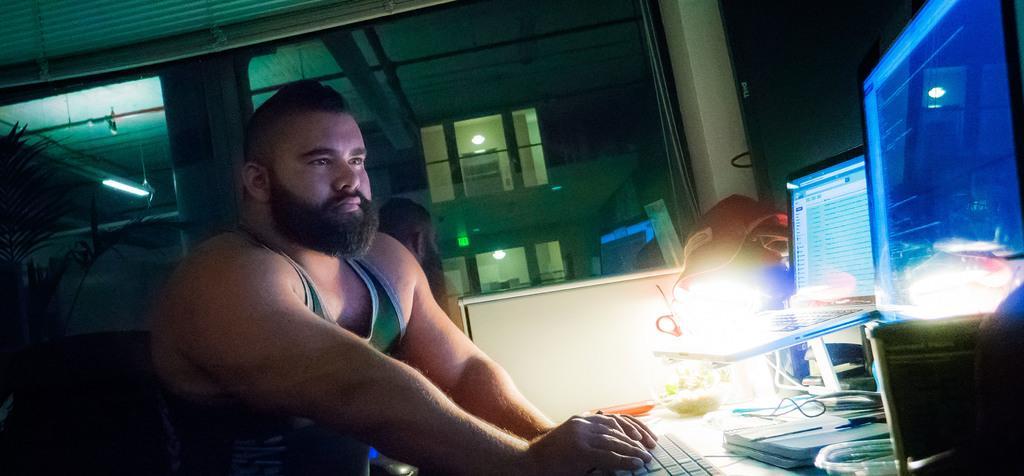Describe this image in one or two sentences. In this picture we can see a man sitting in front of the monitor typing on keyboard and on this table we can see cap, one more laptop on the stand and we have some wires. Here it is a chair and in the background we can see tree, light, pillar, window. 